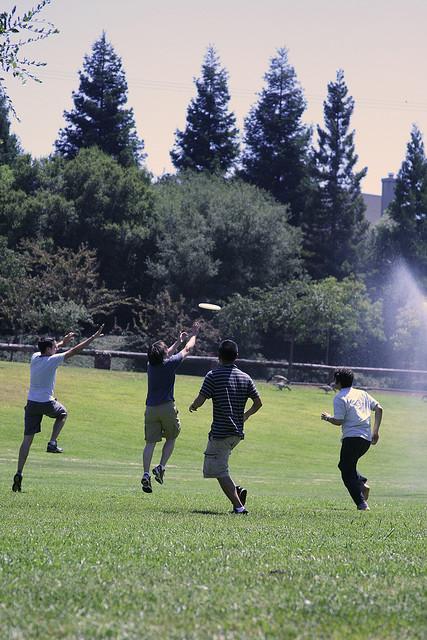How many people are there?
Short answer required. 4. How many trees are in the background?
Be succinct. 10. What is floating in the air?
Be succinct. Frisbee. 